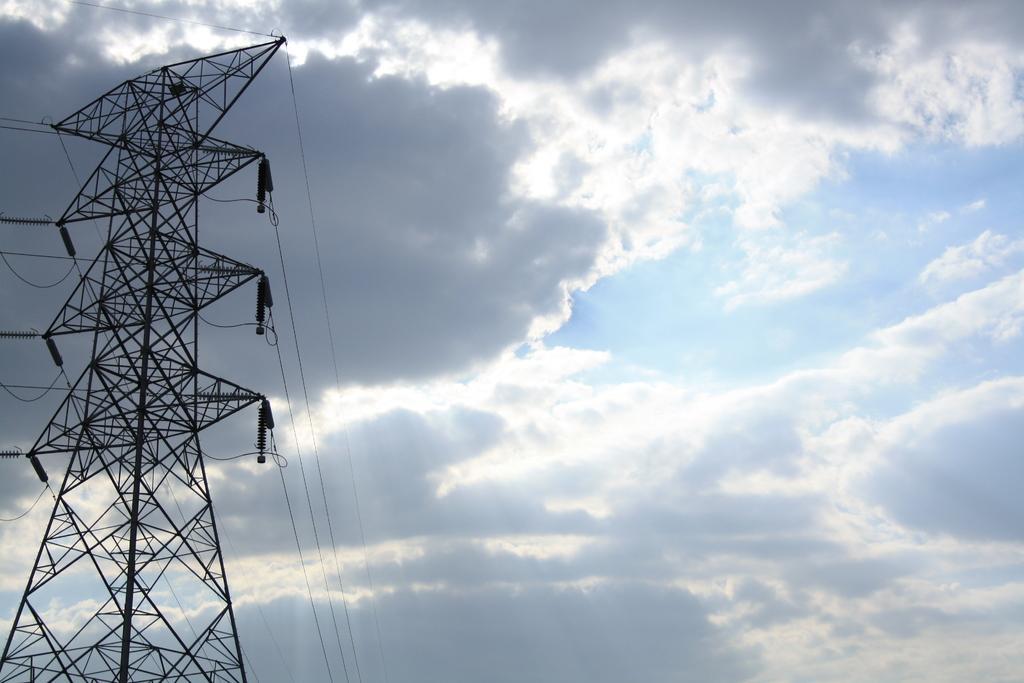Could you give a brief overview of what you see in this image? This picture shows a transmission tower and we see a blue cloudy sky. 